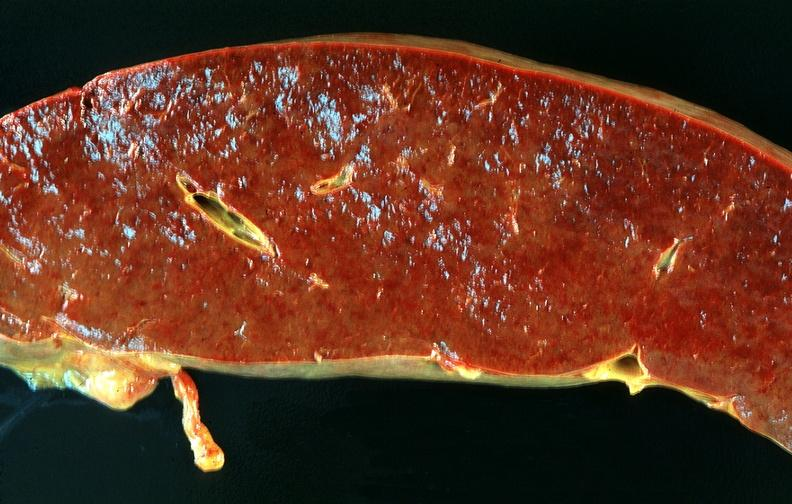why does this image show spleen, chronic congestion?
Answer the question using a single word or phrase. Due to portal hypertension from cirrhosis hcv 